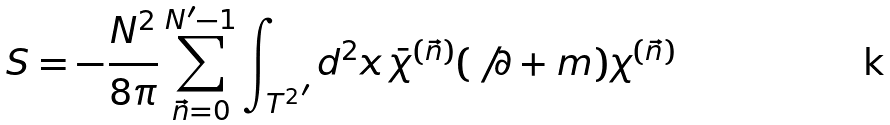Convert formula to latex. <formula><loc_0><loc_0><loc_500><loc_500>S = - \frac { N ^ { 2 } } { 8 \pi } \sum _ { \vec { n } = 0 } ^ { N ^ { \prime } - 1 } \int _ { { T ^ { 2 } } ^ { \prime } } d ^ { 2 } x \, \bar { \chi } ^ { ( \vec { n } ) } ( \, \not \, \partial + m ) \chi ^ { ( \vec { n } ) }</formula> 